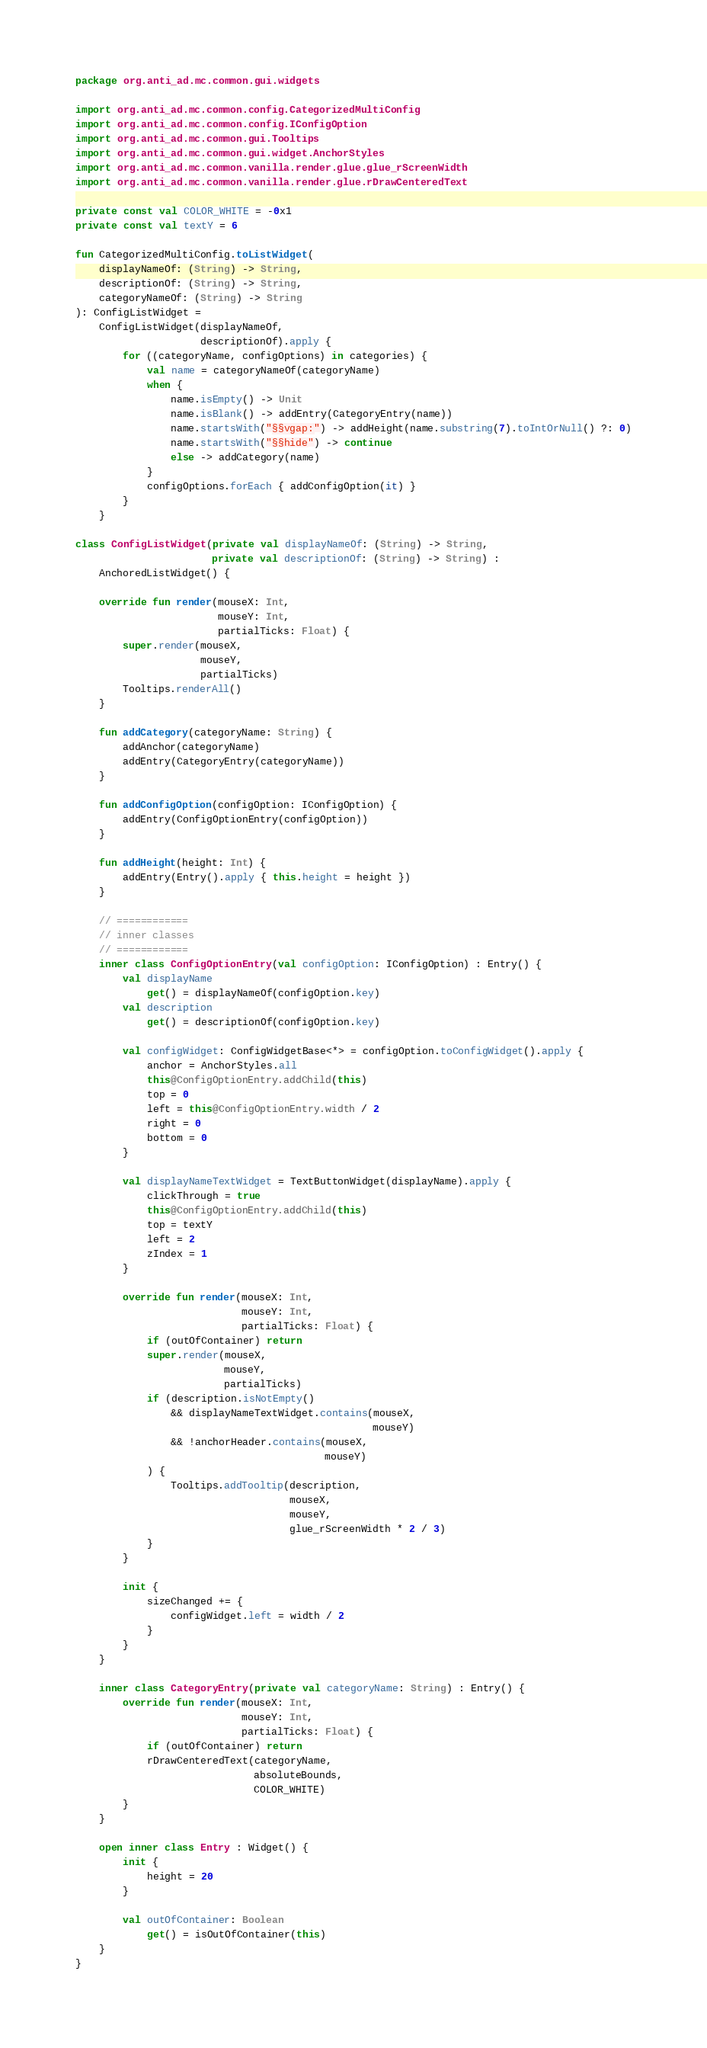Convert code to text. <code><loc_0><loc_0><loc_500><loc_500><_Kotlin_>package org.anti_ad.mc.common.gui.widgets

import org.anti_ad.mc.common.config.CategorizedMultiConfig
import org.anti_ad.mc.common.config.IConfigOption
import org.anti_ad.mc.common.gui.Tooltips
import org.anti_ad.mc.common.gui.widget.AnchorStyles
import org.anti_ad.mc.common.vanilla.render.glue.glue_rScreenWidth
import org.anti_ad.mc.common.vanilla.render.glue.rDrawCenteredText

private const val COLOR_WHITE = -0x1
private const val textY = 6

fun CategorizedMultiConfig.toListWidget(
    displayNameOf: (String) -> String,
    descriptionOf: (String) -> String,
    categoryNameOf: (String) -> String
): ConfigListWidget =
    ConfigListWidget(displayNameOf,
                     descriptionOf).apply {
        for ((categoryName, configOptions) in categories) {
            val name = categoryNameOf(categoryName)
            when {
                name.isEmpty() -> Unit
                name.isBlank() -> addEntry(CategoryEntry(name))
                name.startsWith("§§vgap:") -> addHeight(name.substring(7).toIntOrNull() ?: 0)
                name.startsWith("§§hide") -> continue
                else -> addCategory(name)
            }
            configOptions.forEach { addConfigOption(it) }
        }
    }

class ConfigListWidget(private val displayNameOf: (String) -> String,
                       private val descriptionOf: (String) -> String) :
    AnchoredListWidget() {

    override fun render(mouseX: Int,
                        mouseY: Int,
                        partialTicks: Float) {
        super.render(mouseX,
                     mouseY,
                     partialTicks)
        Tooltips.renderAll()
    }

    fun addCategory(categoryName: String) {
        addAnchor(categoryName)
        addEntry(CategoryEntry(categoryName))
    }

    fun addConfigOption(configOption: IConfigOption) {
        addEntry(ConfigOptionEntry(configOption))
    }

    fun addHeight(height: Int) {
        addEntry(Entry().apply { this.height = height })
    }

    // ============
    // inner classes
    // ============
    inner class ConfigOptionEntry(val configOption: IConfigOption) : Entry() {
        val displayName
            get() = displayNameOf(configOption.key)
        val description
            get() = descriptionOf(configOption.key)

        val configWidget: ConfigWidgetBase<*> = configOption.toConfigWidget().apply {
            anchor = AnchorStyles.all
            this@ConfigOptionEntry.addChild(this)
            top = 0
            left = this@ConfigOptionEntry.width / 2
            right = 0
            bottom = 0
        }

        val displayNameTextWidget = TextButtonWidget(displayName).apply {
            clickThrough = true
            this@ConfigOptionEntry.addChild(this)
            top = textY
            left = 2
            zIndex = 1
        }

        override fun render(mouseX: Int,
                            mouseY: Int,
                            partialTicks: Float) {
            if (outOfContainer) return
            super.render(mouseX,
                         mouseY,
                         partialTicks)
            if (description.isNotEmpty()
                && displayNameTextWidget.contains(mouseX,
                                                  mouseY)
                && !anchorHeader.contains(mouseX,
                                          mouseY)
            ) {
                Tooltips.addTooltip(description,
                                    mouseX,
                                    mouseY,
                                    glue_rScreenWidth * 2 / 3)
            }
        }

        init {
            sizeChanged += {
                configWidget.left = width / 2
            }
        }
    }

    inner class CategoryEntry(private val categoryName: String) : Entry() {
        override fun render(mouseX: Int,
                            mouseY: Int,
                            partialTicks: Float) {
            if (outOfContainer) return
            rDrawCenteredText(categoryName,
                              absoluteBounds,
                              COLOR_WHITE)
        }
    }

    open inner class Entry : Widget() {
        init {
            height = 20
        }

        val outOfContainer: Boolean
            get() = isOutOfContainer(this)
    }
}</code> 